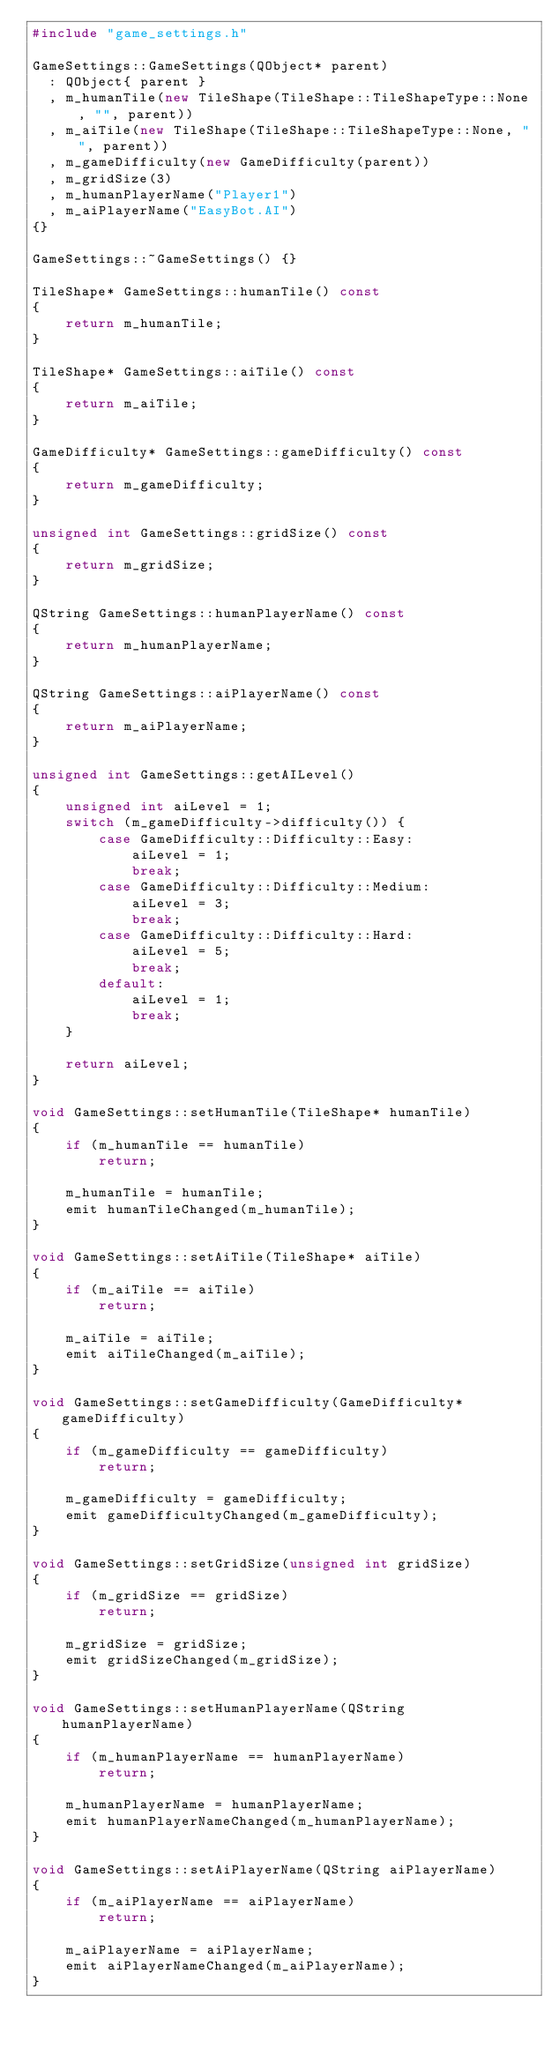<code> <loc_0><loc_0><loc_500><loc_500><_C++_>#include "game_settings.h"

GameSettings::GameSettings(QObject* parent)
  : QObject{ parent }
  , m_humanTile(new TileShape(TileShape::TileShapeType::None, "", parent))
  , m_aiTile(new TileShape(TileShape::TileShapeType::None, "", parent))
  , m_gameDifficulty(new GameDifficulty(parent))
  , m_gridSize(3)
  , m_humanPlayerName("Player1")
  , m_aiPlayerName("EasyBot.AI")
{}

GameSettings::~GameSettings() {}

TileShape* GameSettings::humanTile() const
{
    return m_humanTile;
}

TileShape* GameSettings::aiTile() const
{
    return m_aiTile;
}

GameDifficulty* GameSettings::gameDifficulty() const
{
    return m_gameDifficulty;
}

unsigned int GameSettings::gridSize() const
{
    return m_gridSize;
}

QString GameSettings::humanPlayerName() const
{
    return m_humanPlayerName;
}

QString GameSettings::aiPlayerName() const
{
    return m_aiPlayerName;
}

unsigned int GameSettings::getAILevel()
{
    unsigned int aiLevel = 1;
    switch (m_gameDifficulty->difficulty()) {
        case GameDifficulty::Difficulty::Easy:
            aiLevel = 1;
            break;
        case GameDifficulty::Difficulty::Medium:
            aiLevel = 3;
            break;
        case GameDifficulty::Difficulty::Hard:
            aiLevel = 5;
            break;
        default:
            aiLevel = 1;
            break;
    }

    return aiLevel;
}

void GameSettings::setHumanTile(TileShape* humanTile)
{
    if (m_humanTile == humanTile)
        return;

    m_humanTile = humanTile;
    emit humanTileChanged(m_humanTile);
}

void GameSettings::setAiTile(TileShape* aiTile)
{
    if (m_aiTile == aiTile)
        return;

    m_aiTile = aiTile;
    emit aiTileChanged(m_aiTile);
}

void GameSettings::setGameDifficulty(GameDifficulty* gameDifficulty)
{
    if (m_gameDifficulty == gameDifficulty)
        return;

    m_gameDifficulty = gameDifficulty;
    emit gameDifficultyChanged(m_gameDifficulty);
}

void GameSettings::setGridSize(unsigned int gridSize)
{
    if (m_gridSize == gridSize)
        return;

    m_gridSize = gridSize;
    emit gridSizeChanged(m_gridSize);
}

void GameSettings::setHumanPlayerName(QString humanPlayerName)
{
    if (m_humanPlayerName == humanPlayerName)
        return;

    m_humanPlayerName = humanPlayerName;
    emit humanPlayerNameChanged(m_humanPlayerName);
}

void GameSettings::setAiPlayerName(QString aiPlayerName)
{
    if (m_aiPlayerName == aiPlayerName)
        return;

    m_aiPlayerName = aiPlayerName;
    emit aiPlayerNameChanged(m_aiPlayerName);
}
</code> 